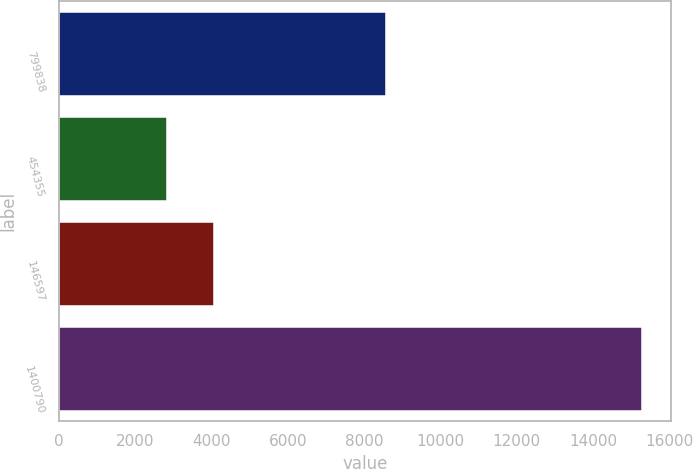Convert chart. <chart><loc_0><loc_0><loc_500><loc_500><bar_chart><fcel>799838<fcel>454355<fcel>146597<fcel>1400790<nl><fcel>8564<fcel>2827<fcel>4071.7<fcel>15274<nl></chart> 